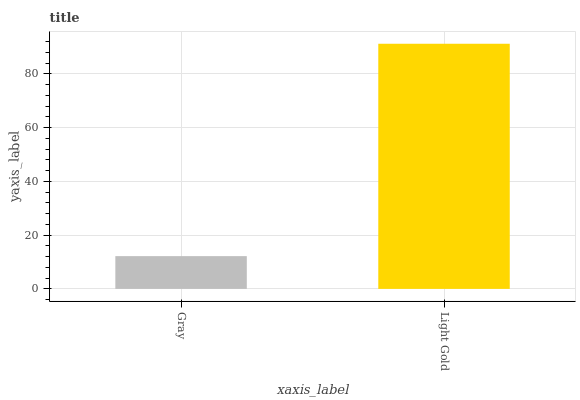Is Gray the minimum?
Answer yes or no. Yes. Is Light Gold the maximum?
Answer yes or no. Yes. Is Light Gold the minimum?
Answer yes or no. No. Is Light Gold greater than Gray?
Answer yes or no. Yes. Is Gray less than Light Gold?
Answer yes or no. Yes. Is Gray greater than Light Gold?
Answer yes or no. No. Is Light Gold less than Gray?
Answer yes or no. No. Is Light Gold the high median?
Answer yes or no. Yes. Is Gray the low median?
Answer yes or no. Yes. Is Gray the high median?
Answer yes or no. No. Is Light Gold the low median?
Answer yes or no. No. 